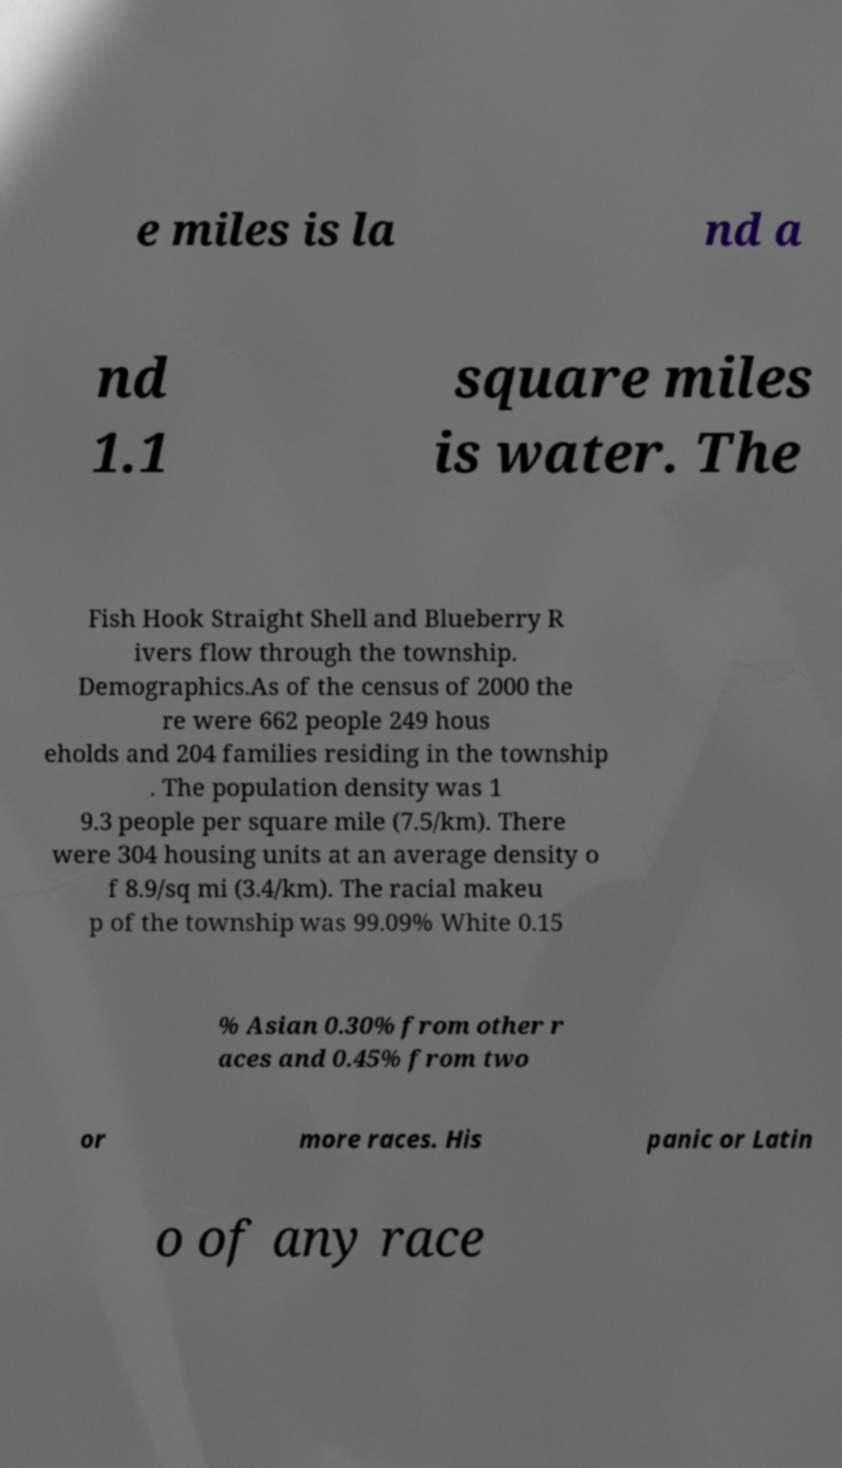Could you assist in decoding the text presented in this image and type it out clearly? e miles is la nd a nd 1.1 square miles is water. The Fish Hook Straight Shell and Blueberry R ivers flow through the township. Demographics.As of the census of 2000 the re were 662 people 249 hous eholds and 204 families residing in the township . The population density was 1 9.3 people per square mile (7.5/km). There were 304 housing units at an average density o f 8.9/sq mi (3.4/km). The racial makeu p of the township was 99.09% White 0.15 % Asian 0.30% from other r aces and 0.45% from two or more races. His panic or Latin o of any race 